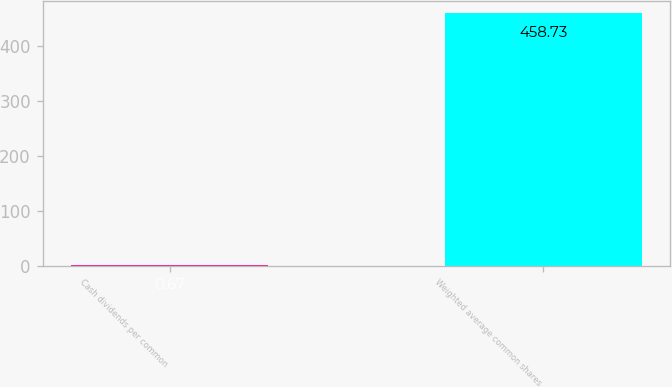Convert chart to OTSL. <chart><loc_0><loc_0><loc_500><loc_500><bar_chart><fcel>Cash dividends per common<fcel>Weighted average common shares<nl><fcel>0.67<fcel>458.73<nl></chart> 